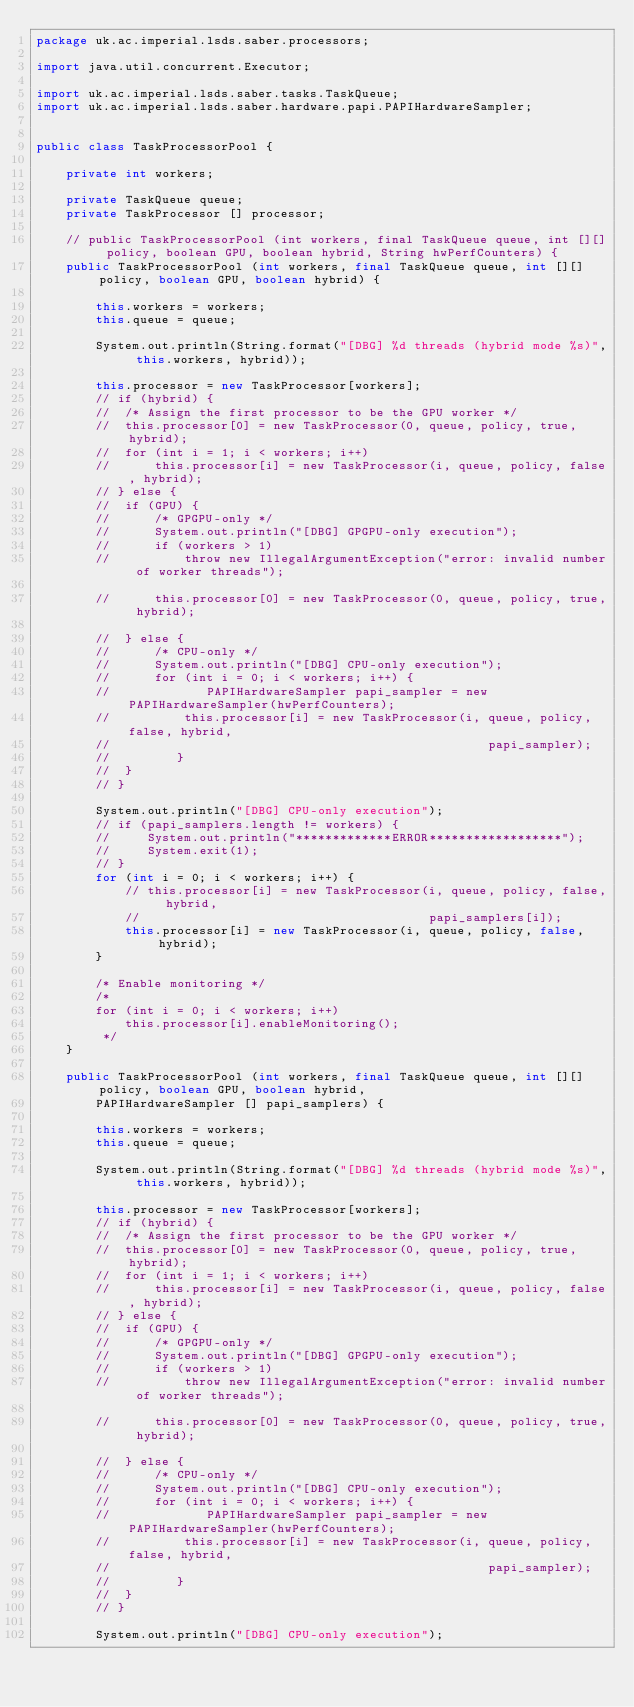Convert code to text. <code><loc_0><loc_0><loc_500><loc_500><_Java_>package uk.ac.imperial.lsds.saber.processors;

import java.util.concurrent.Executor;

import uk.ac.imperial.lsds.saber.tasks.TaskQueue;
import uk.ac.imperial.lsds.saber.hardware.papi.PAPIHardwareSampler;


public class TaskProcessorPool {

	private int workers;

	private TaskQueue queue;
	private TaskProcessor [] processor;

	// public TaskProcessorPool (int workers, final TaskQueue queue, int [][] policy, boolean GPU, boolean hybrid, String hwPerfCounters) {
    public TaskProcessorPool (int workers, final TaskQueue queue, int [][] policy, boolean GPU, boolean hybrid) {

		this.workers = workers;
		this.queue = queue;

		System.out.println(String.format("[DBG] %d threads (hybrid mode %s)", this.workers, hybrid));

		this.processor = new TaskProcessor[workers];
		// if (hybrid) {
		// 	/* Assign the first processor to be the GPU worker */
		// 	this.processor[0] = new TaskProcessor(0, queue, policy, true, hybrid);
		// 	for (int i = 1; i < workers; i++)
		// 		this.processor[i] = new TaskProcessor(i, queue, policy, false, hybrid);
		// } else {
		// 	if (GPU) {
		// 		/* GPGPU-only */
		// 		System.out.println("[DBG] GPGPU-only execution");
		// 		if (workers > 1)
		// 			throw new IllegalArgumentException("error: invalid number of worker threads");

		// 		this.processor[0] = new TaskProcessor(0, queue, policy, true, hybrid);

		// 	} else {
		// 		/* CPU-only */
		// 		System.out.println("[DBG] CPU-only execution");
		// 		for (int i = 0; i < workers; i++) {
        //             PAPIHardwareSampler papi_sampler = new PAPIHardwareSampler(hwPerfCounters);
		// 			this.processor[i] = new TaskProcessor(i, queue, policy, false, hybrid,
        //                                                   papi_sampler);
        //         }
		// 	}
		// }

        System.out.println("[DBG] CPU-only execution");
        // if (papi_samplers.length != workers) {
        //     System.out.println("*************ERROR******************");
        //     System.exit(1);
        // }
        for (int i = 0; i < workers; i++) {
            // this.processor[i] = new TaskProcessor(i, queue, policy, false, hybrid,
            //                                       papi_samplers[i]);
            this.processor[i] = new TaskProcessor(i, queue, policy, false, hybrid);
        }

		/* Enable monitoring */
		/*
		for (int i = 0; i < workers; i++)
			this.processor[i].enableMonitoring();
		 */
	}

    public TaskProcessorPool (int workers, final TaskQueue queue, int [][] policy, boolean GPU, boolean hybrid,
        PAPIHardwareSampler [] papi_samplers) {

		this.workers = workers;
		this.queue = queue;

		System.out.println(String.format("[DBG] %d threads (hybrid mode %s)", this.workers, hybrid));

		this.processor = new TaskProcessor[workers];
		// if (hybrid) {
		// 	/* Assign the first processor to be the GPU worker */
		// 	this.processor[0] = new TaskProcessor(0, queue, policy, true, hybrid);
		// 	for (int i = 1; i < workers; i++)
		// 		this.processor[i] = new TaskProcessor(i, queue, policy, false, hybrid);
		// } else {
		// 	if (GPU) {
		// 		/* GPGPU-only */
		// 		System.out.println("[DBG] GPGPU-only execution");
		// 		if (workers > 1)
		// 			throw new IllegalArgumentException("error: invalid number of worker threads");

		// 		this.processor[0] = new TaskProcessor(0, queue, policy, true, hybrid);

		// 	} else {
		// 		/* CPU-only */
		// 		System.out.println("[DBG] CPU-only execution");
		// 		for (int i = 0; i < workers; i++) {
        //             PAPIHardwareSampler papi_sampler = new PAPIHardwareSampler(hwPerfCounters);
		// 			this.processor[i] = new TaskProcessor(i, queue, policy, false, hybrid,
        //                                                   papi_sampler);
        //         }
		// 	}
		// }

        System.out.println("[DBG] CPU-only execution");</code> 